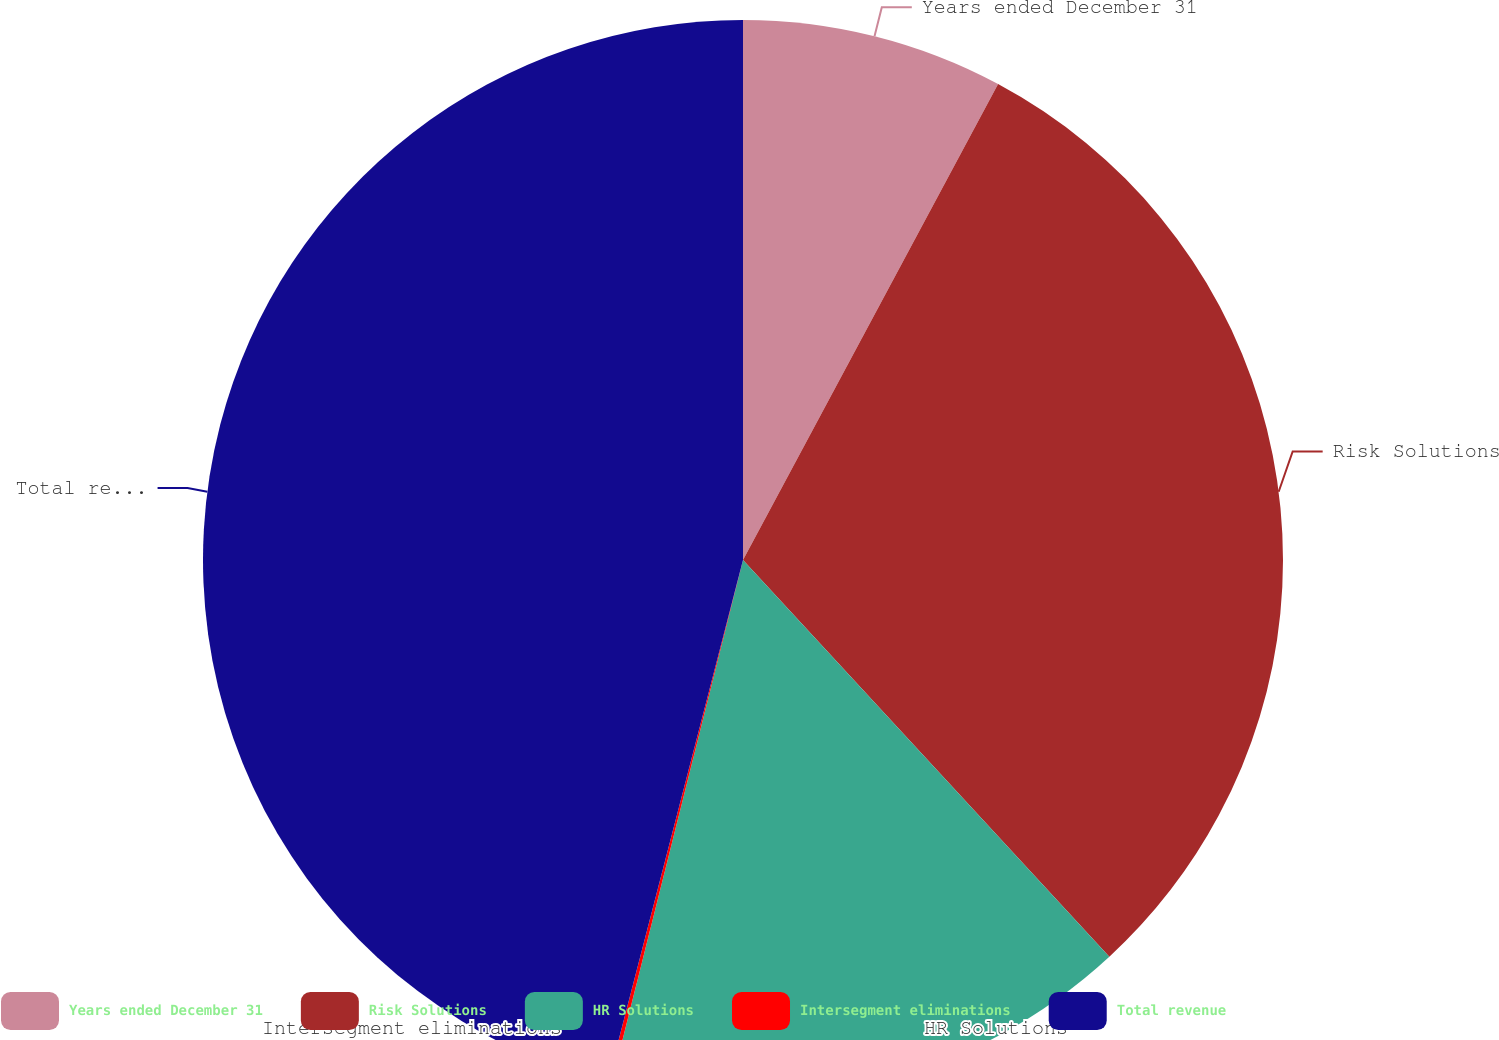Convert chart to OTSL. <chart><loc_0><loc_0><loc_500><loc_500><pie_chart><fcel>Years ended December 31<fcel>Risk Solutions<fcel>HR Solutions<fcel>Intersegment eliminations<fcel>Total revenue<nl><fcel>7.83%<fcel>30.3%<fcel>15.78%<fcel>0.12%<fcel>45.96%<nl></chart> 